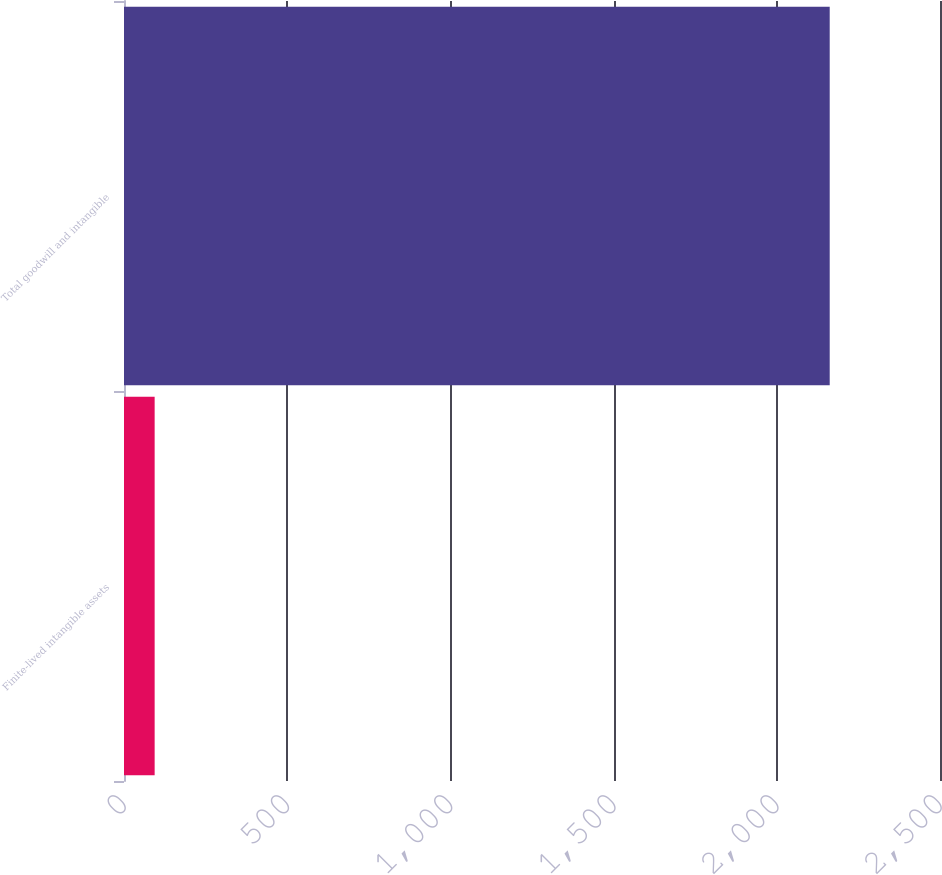Convert chart to OTSL. <chart><loc_0><loc_0><loc_500><loc_500><bar_chart><fcel>Finite-lived intangible assets<fcel>Total goodwill and intangible<nl><fcel>93.9<fcel>2162.1<nl></chart> 